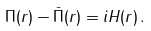<formula> <loc_0><loc_0><loc_500><loc_500>\Pi ( r ) - \bar { \Pi } ( r ) = i H ( r ) \, .</formula> 